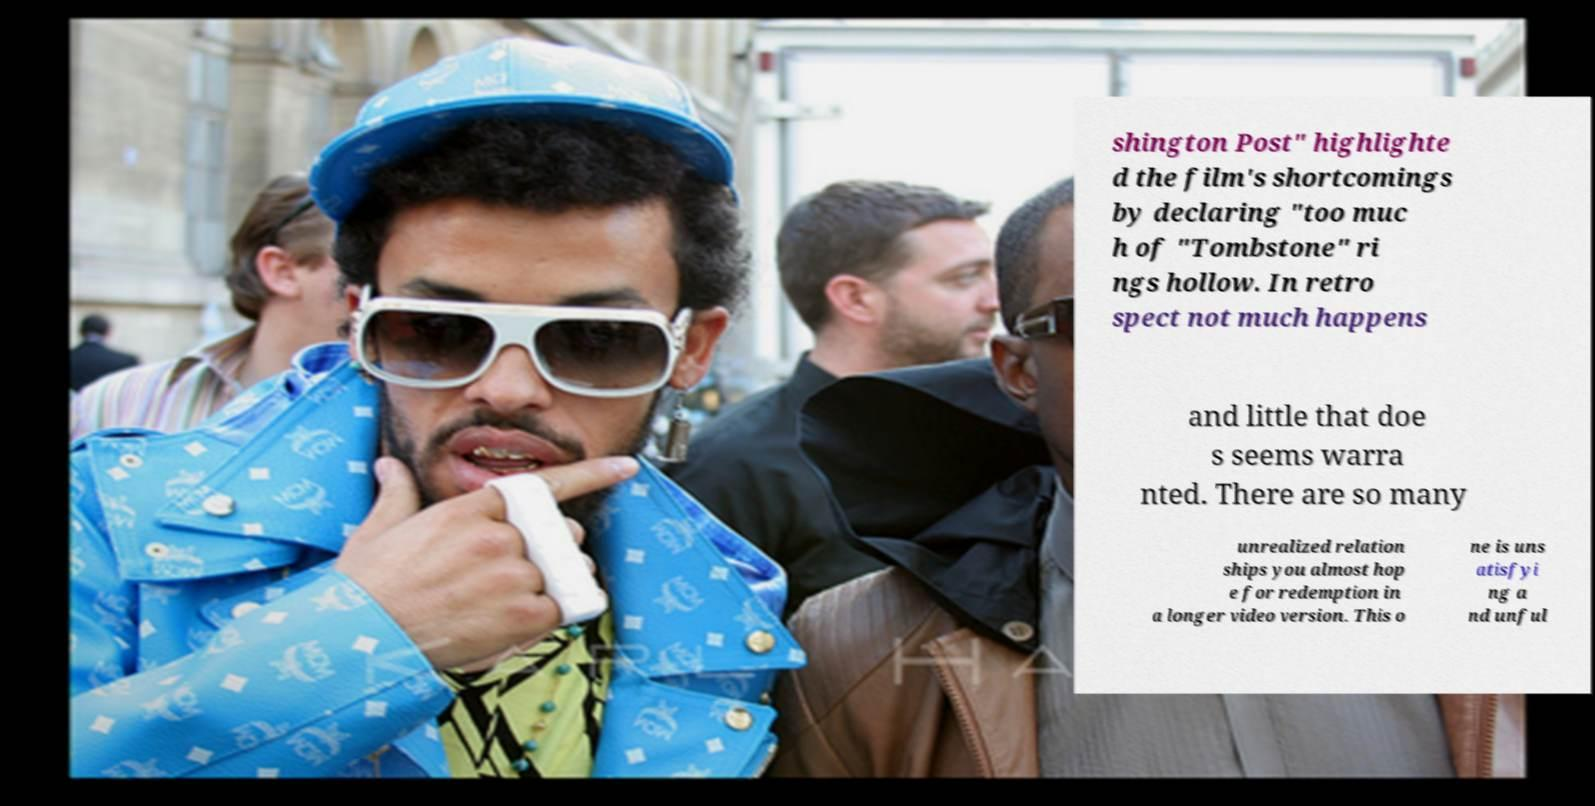Can you accurately transcribe the text from the provided image for me? shington Post" highlighte d the film's shortcomings by declaring "too muc h of "Tombstone" ri ngs hollow. In retro spect not much happens and little that doe s seems warra nted. There are so many unrealized relation ships you almost hop e for redemption in a longer video version. This o ne is uns atisfyi ng a nd unful 